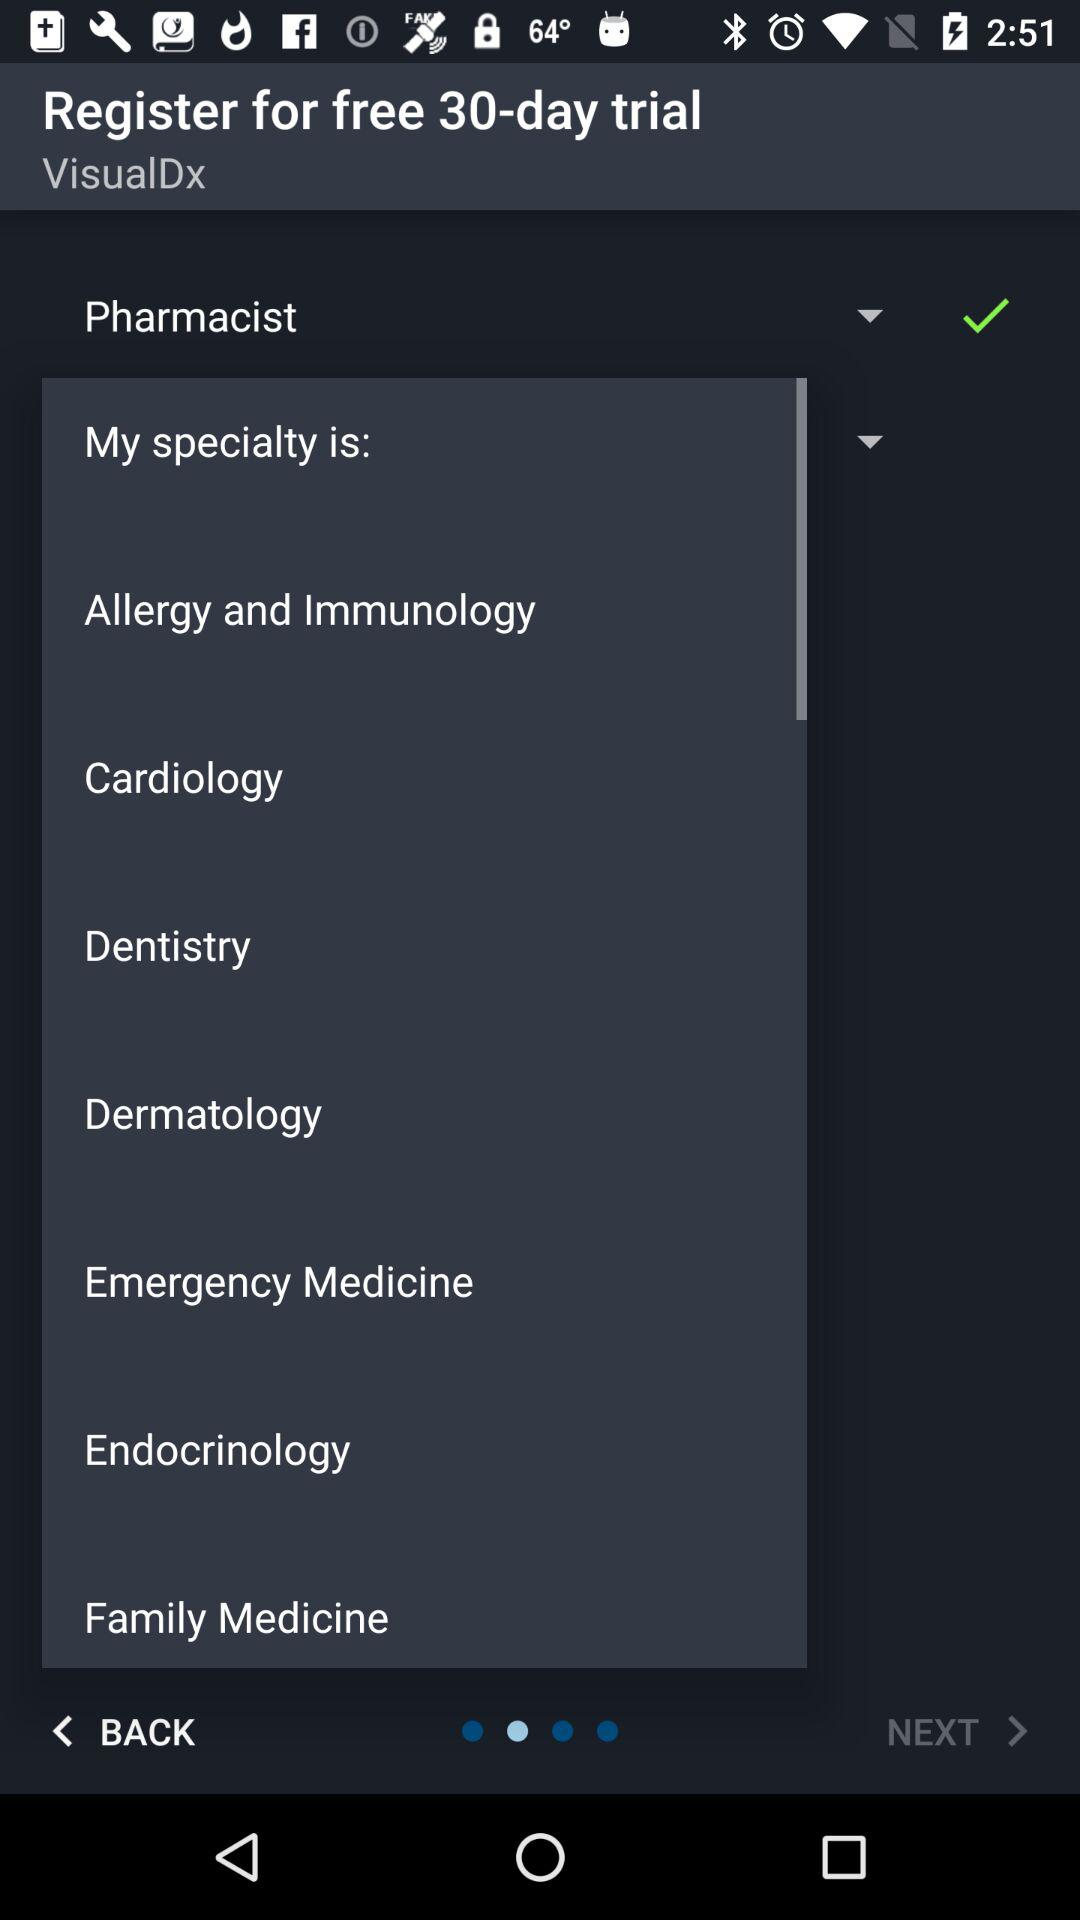Which profession is selected? The selected profession is "Pharmacist". 